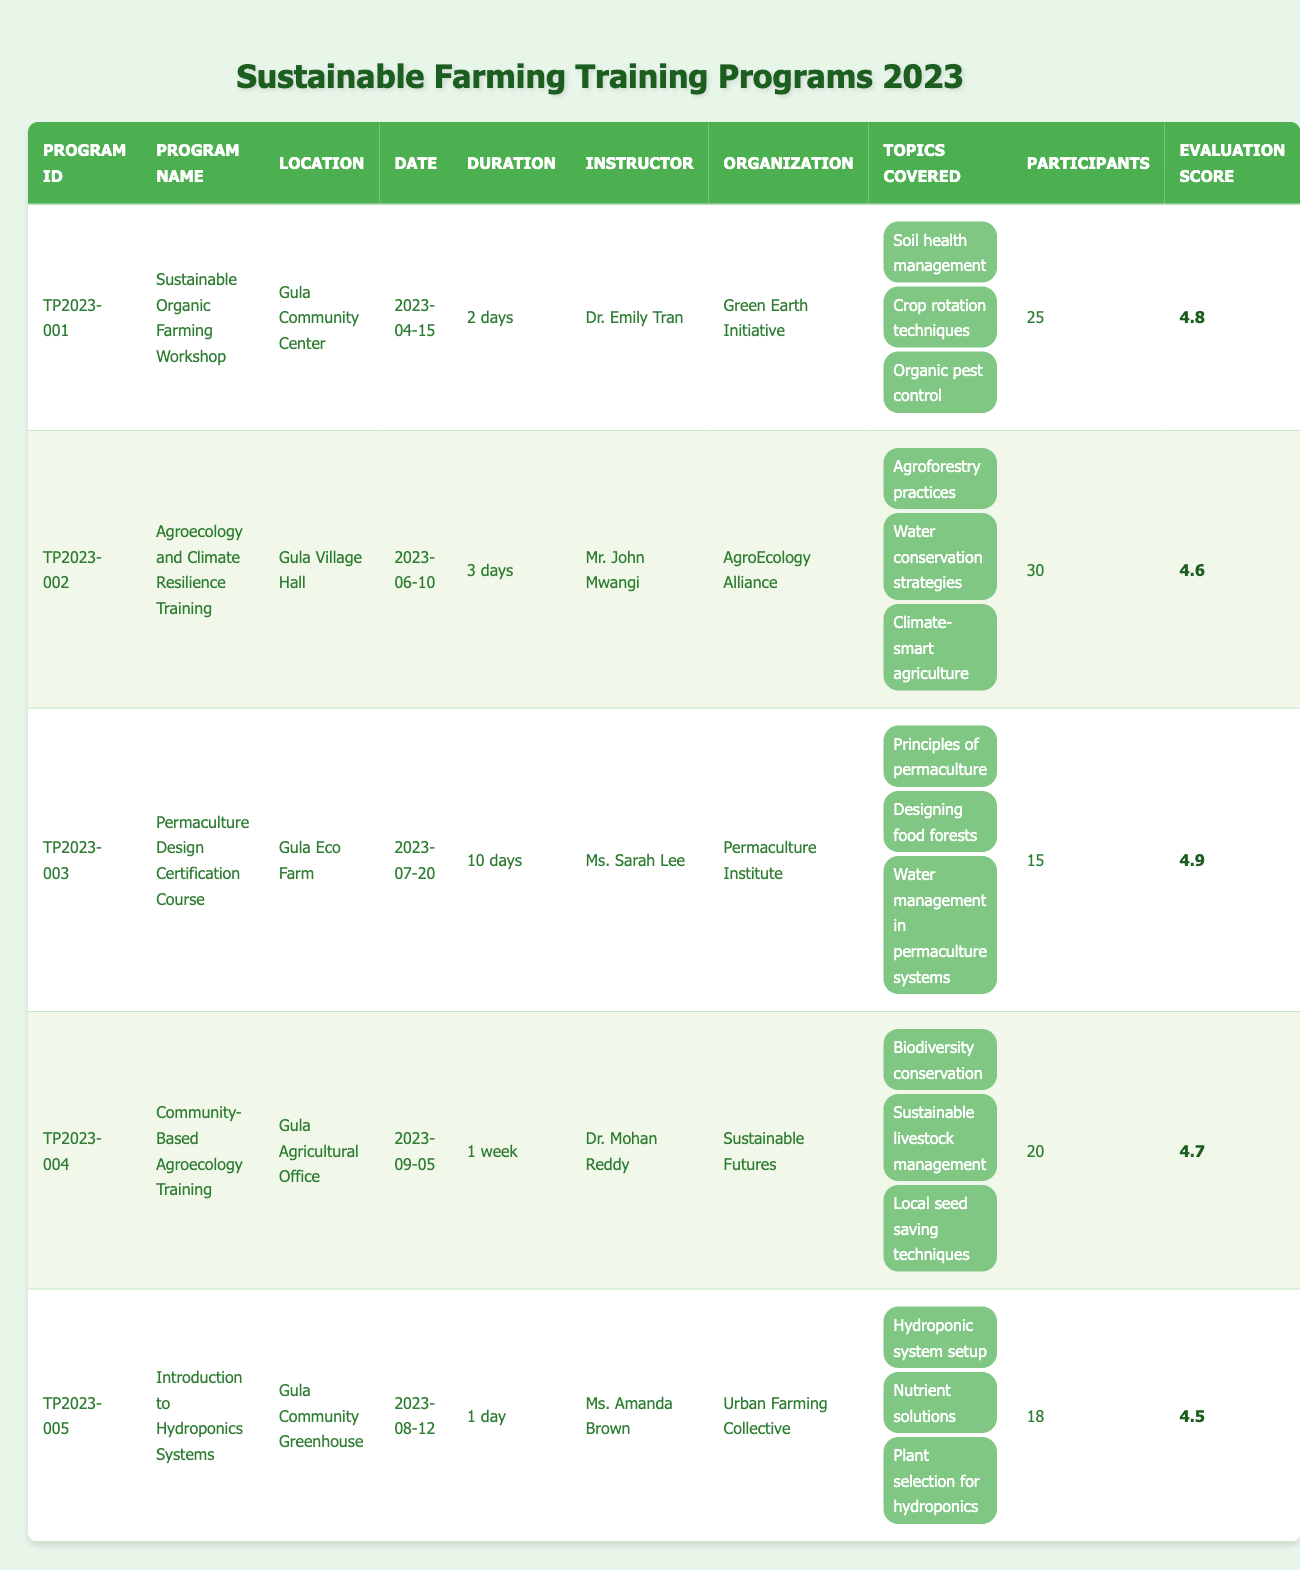What is the program with the highest evaluation score? By examining the "Evaluation Score" column of the table, the highest score is 4.9, which corresponds to the "Permaculture Design Certification Course"
Answer: Permaculture Design Certification Course How many participants attended the "Agroecology and Climate Resilience Training"? Looking at the "Participants" column for the "Agroecology and Climate Resilience Training", it shows that 30 participants attended this program
Answer: 30 Did the "Introduction to Hydroponics Systems" program last longer than 1 day? The "Duration" column for the "Introduction to Hydroponics Systems" indicates that it lasted for 1 day, so the answer is no
Answer: No What is the average number of participants across all training programs? To find the average number of participants, first add the number of participants: 25 + 30 + 15 + 20 + 18 = 108. Then, divide by the number of programs (5), giving 108/5 = 21.6
Answer: 21.6 Which training program was conducted at the Gula Agricultural Office? The table shows that the program held at the "Gula Agricultural Office" is the "Community-Based Agroecology Training"
Answer: Community-Based Agroecology Training How many topics were covered in the "Sustainable Organic Farming Workshop"? The "Topics Covered" column for the "Sustainable Organic Farming Workshop" lists 3 topics, namely "Soil health management," "Crop rotation techniques," and "Organic pest control"
Answer: 3 Which instructor taught the program focused on hydroponics? By looking at the "Instructor" column for the program named "Introduction to Hydroponics Systems," we find that it was taught by Ms. Amanda Brown
Answer: Ms. Amanda Brown Did the "Sustainable Organic Farming Workshop" take place before the "Community-Based Agroecology Training"? The "Date" column indicates that the "Sustainable Organic Farming Workshop" was held on April 15, 2023, while the "Community-Based Agroecology Training" took place on September 5, 2023, confirming that the former occurred first
Answer: Yes What is the total duration of the four longest training programs? The durations for the four longest programs are 10 days (Permaculture), 7 days (Community-Based Agroecology), 3 days (Agroecology), and 2 days (Sustainable Organic). Converting them all to days: 10 + 7 + 3 + 2 = 22
Answer: 22 